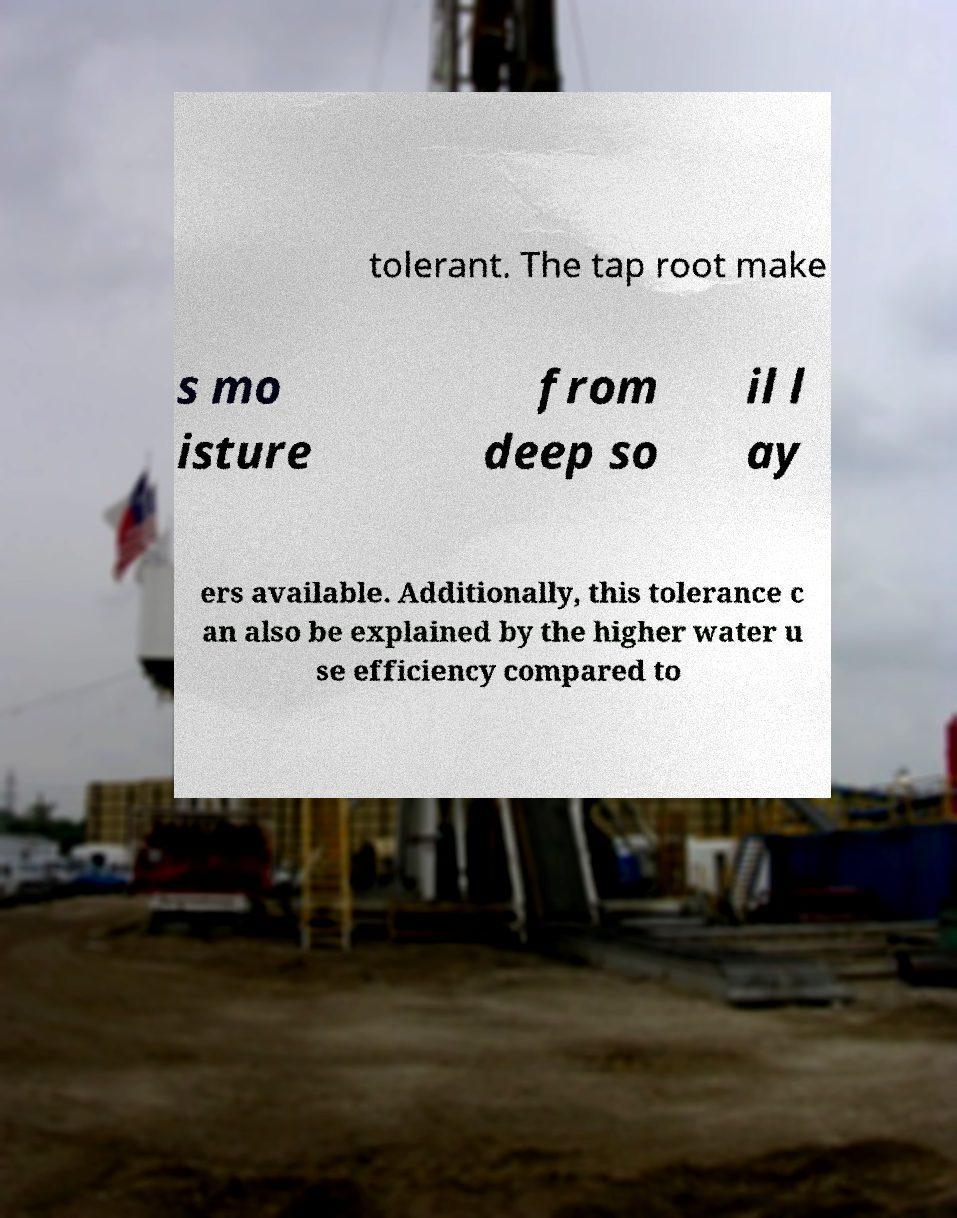Can you read and provide the text displayed in the image?This photo seems to have some interesting text. Can you extract and type it out for me? tolerant. The tap root make s mo isture from deep so il l ay ers available. Additionally, this tolerance c an also be explained by the higher water u se efficiency compared to 